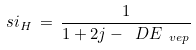Convert formula to latex. <formula><loc_0><loc_0><loc_500><loc_500>\ s i _ { H } \, = \, \frac { 1 } { 1 + 2 j - \ D E _ { \ v e p } }</formula> 